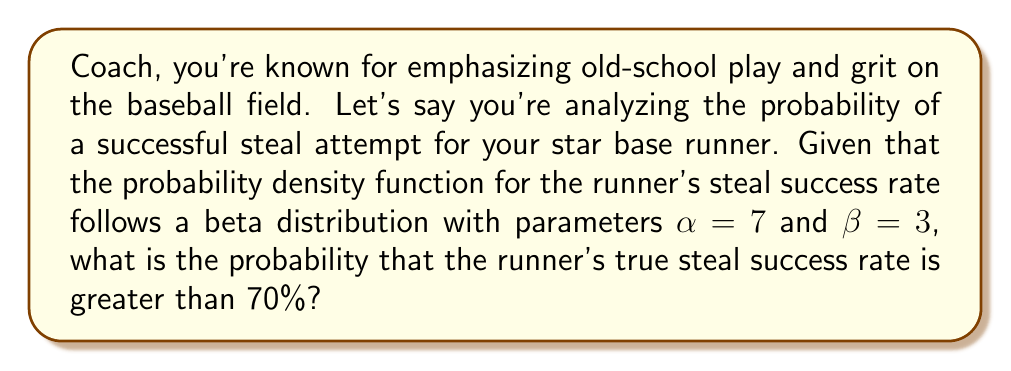Help me with this question. To solve this problem, we'll use the beta distribution, which is commonly used to model probabilities. The probability density function (PDF) of a beta distribution with parameters $\alpha$ and $\beta$ is given by:

$$f(x; \alpha, \beta) = \frac{x^{\alpha-1}(1-x)^{\beta-1}}{B(\alpha, \beta)}$$

where $B(\alpha, \beta)$ is the beta function.

We want to find $P(X > 0.7)$, where $X$ is the random variable representing the steal success rate.

To calculate this, we need to integrate the PDF from 0.7 to 1:

$$P(X > 0.7) = \int_{0.7}^{1} \frac{x^{6}(1-x)^{2}}{B(7,3)} dx$$

This integral doesn't have a simple closed-form solution, so we'll use the regularized incomplete beta function, which is defined as:

$$I_x(\alpha, \beta) = \frac{B(x; \alpha, \beta)}{B(\alpha, \beta)}$$

where $B(x; \alpha, \beta)$ is the incomplete beta function.

The probability we're looking for is:

$$P(X > 0.7) = 1 - I_{0.7}(7, 3)$$

Using a calculator or computational software to evaluate this:

$$P(X > 0.7) \approx 1 - 0.8724 = 0.1276$$

Therefore, the probability that the runner's true steal success rate is greater than 70% is approximately 0.1276 or 12.76%.
Answer: The probability that the runner's true steal success rate is greater than 70% is approximately 0.1276 or 12.76%. 